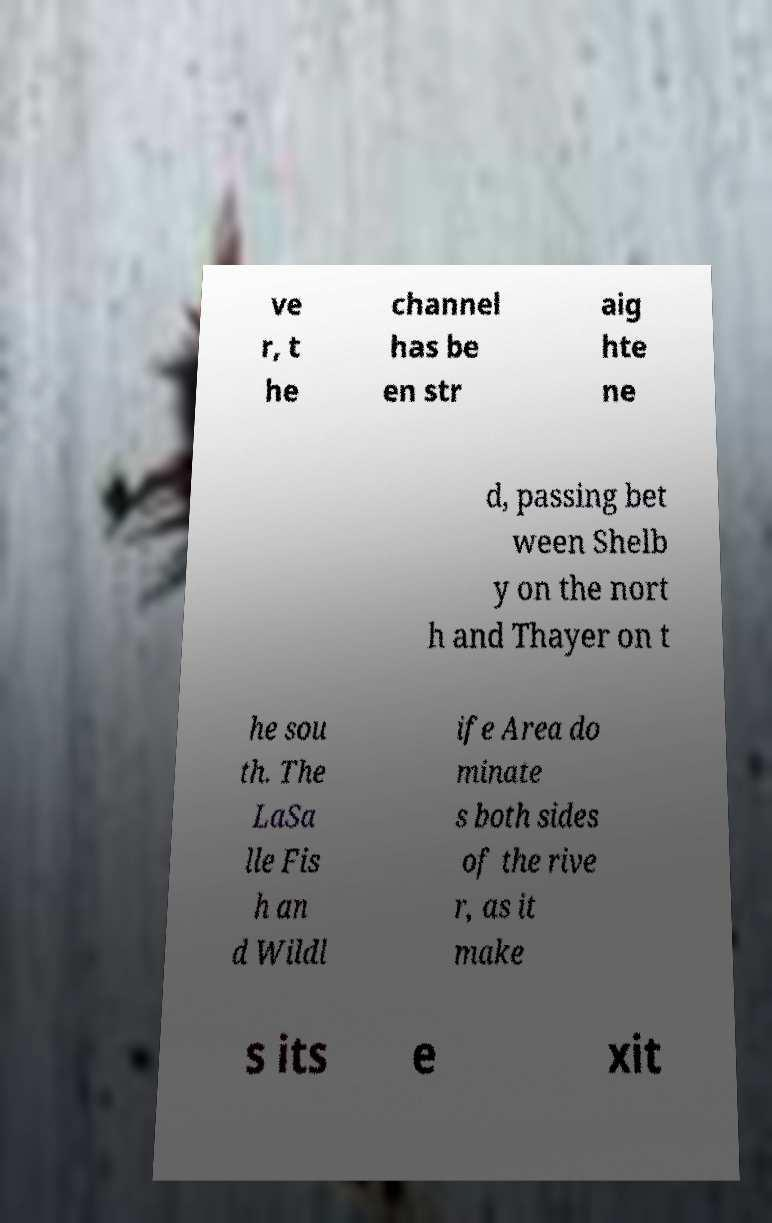For documentation purposes, I need the text within this image transcribed. Could you provide that? ve r, t he channel has be en str aig hte ne d, passing bet ween Shelb y on the nort h and Thayer on t he sou th. The LaSa lle Fis h an d Wildl ife Area do minate s both sides of the rive r, as it make s its e xit 